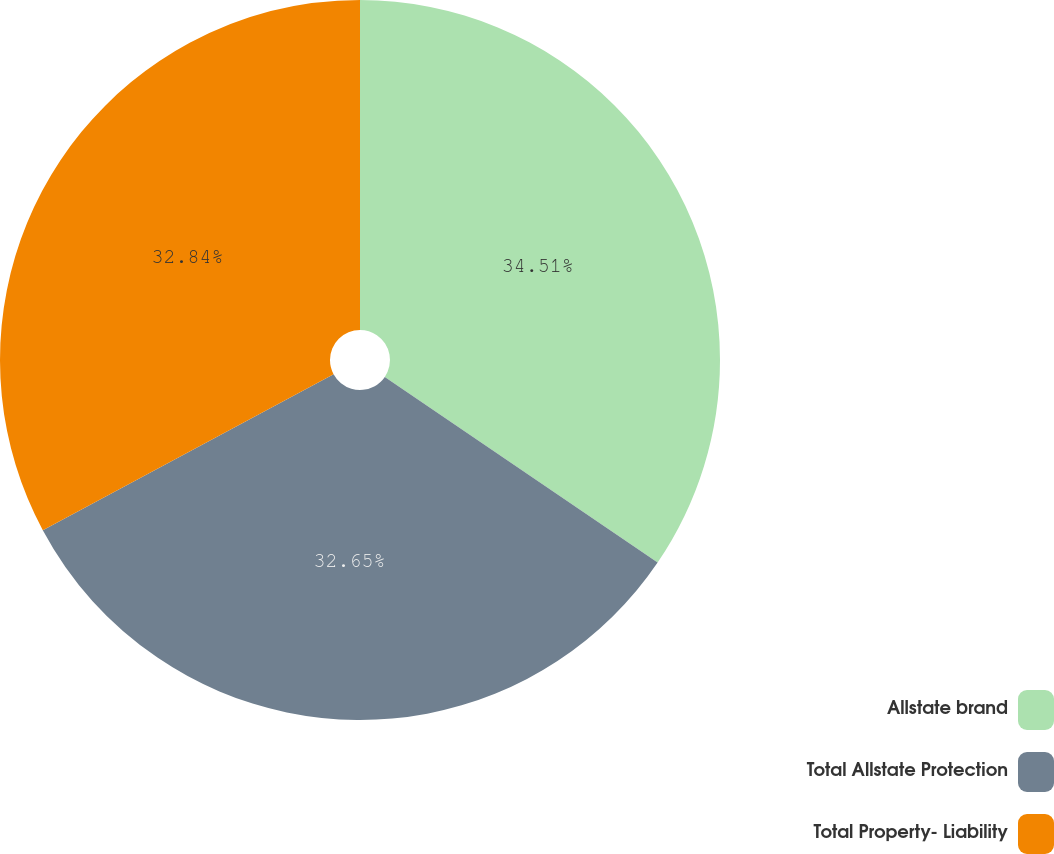Convert chart to OTSL. <chart><loc_0><loc_0><loc_500><loc_500><pie_chart><fcel>Allstate brand<fcel>Total Allstate Protection<fcel>Total Property- Liability<nl><fcel>34.51%<fcel>32.65%<fcel>32.84%<nl></chart> 